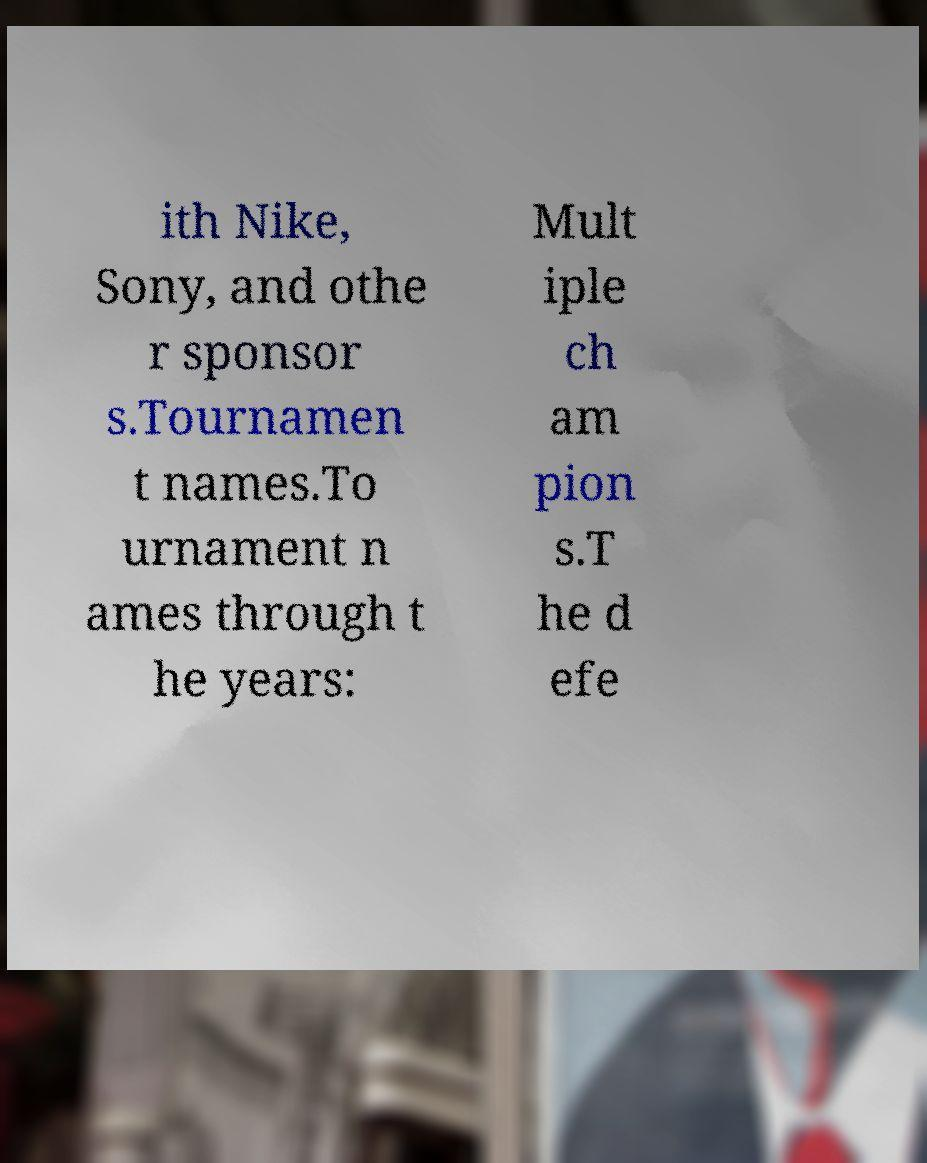There's text embedded in this image that I need extracted. Can you transcribe it verbatim? ith Nike, Sony, and othe r sponsor s.Tournamen t names.To urnament n ames through t he years: Mult iple ch am pion s.T he d efe 